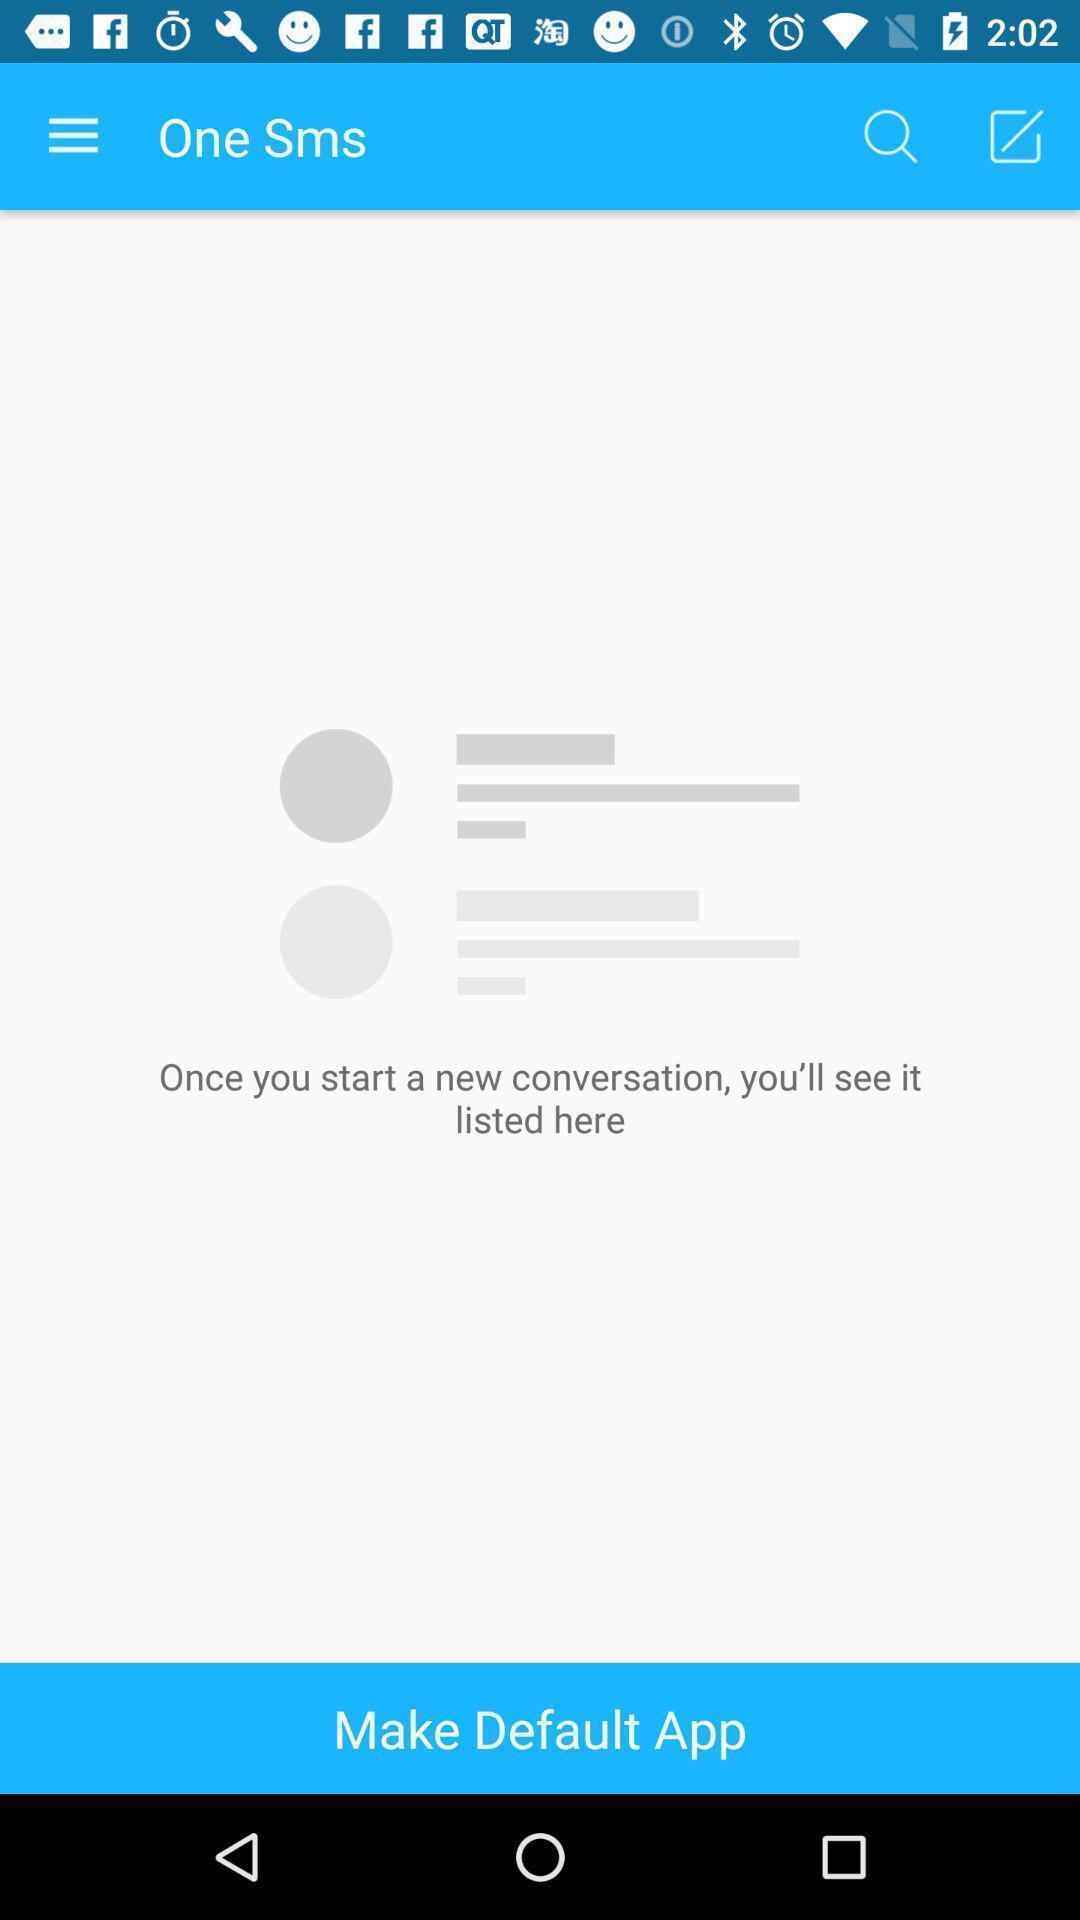Explain the elements present in this screenshot. Screen shows a messaging app. 